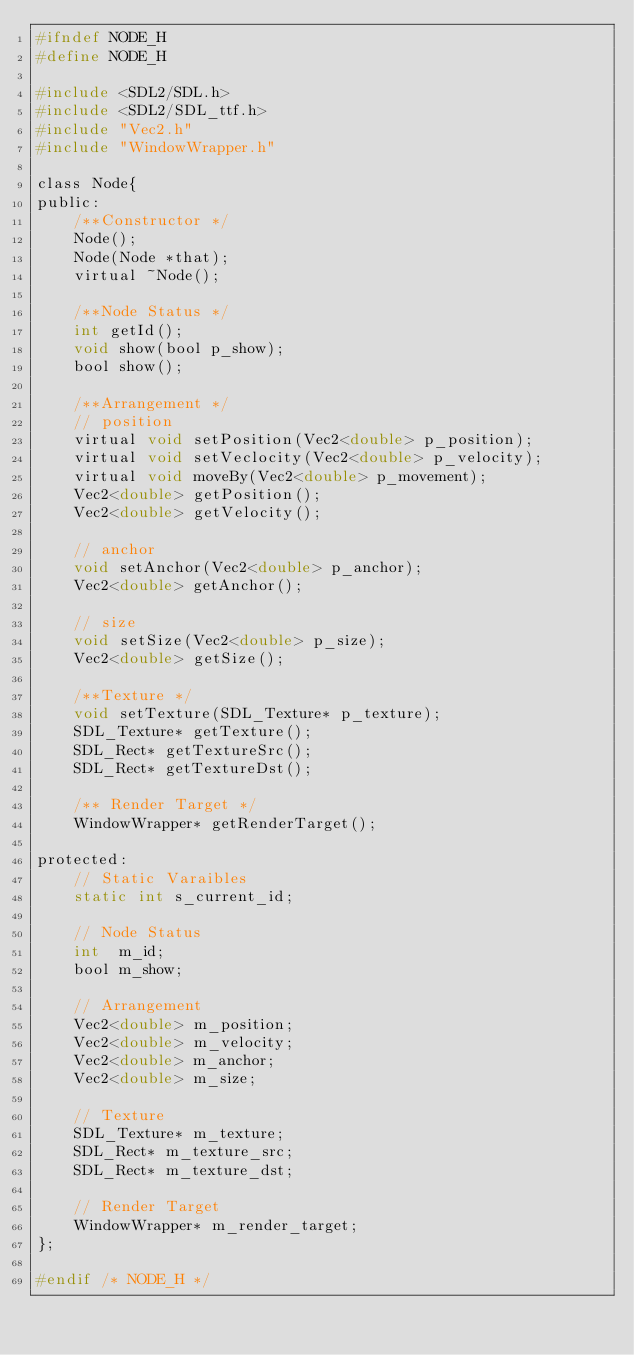<code> <loc_0><loc_0><loc_500><loc_500><_C_>#ifndef NODE_H
#define NODE_H

#include <SDL2/SDL.h>
#include <SDL2/SDL_ttf.h>
#include "Vec2.h"
#include "WindowWrapper.h"

class Node{
public:
    /**Constructor */
    Node();
    Node(Node *that);
    virtual ~Node();

    /**Node Status */
    int getId();
    void show(bool p_show);
    bool show();

    /**Arrangement */
    // position
    virtual void setPosition(Vec2<double> p_position);
    virtual void setVeclocity(Vec2<double> p_velocity);
    virtual void moveBy(Vec2<double> p_movement);
    Vec2<double> getPosition();
    Vec2<double> getVelocity();

    // anchor
    void setAnchor(Vec2<double> p_anchor);
    Vec2<double> getAnchor();

    // size
    void setSize(Vec2<double> p_size);
    Vec2<double> getSize();

    /**Texture */
    void setTexture(SDL_Texture* p_texture);
    SDL_Texture* getTexture();
    SDL_Rect* getTextureSrc();
    SDL_Rect* getTextureDst();
    
    /** Render Target */
    WindowWrapper* getRenderTarget();

protected:
    // Static Varaibles
    static int s_current_id;
    
    // Node Status
    int  m_id;
    bool m_show;

    // Arrangement
    Vec2<double> m_position;
    Vec2<double> m_velocity;
    Vec2<double> m_anchor;
    Vec2<double> m_size;

    // Texture
    SDL_Texture* m_texture;
    SDL_Rect* m_texture_src;
    SDL_Rect* m_texture_dst;
    
    // Render Target
    WindowWrapper* m_render_target;
};

#endif /* NODE_H */
</code> 